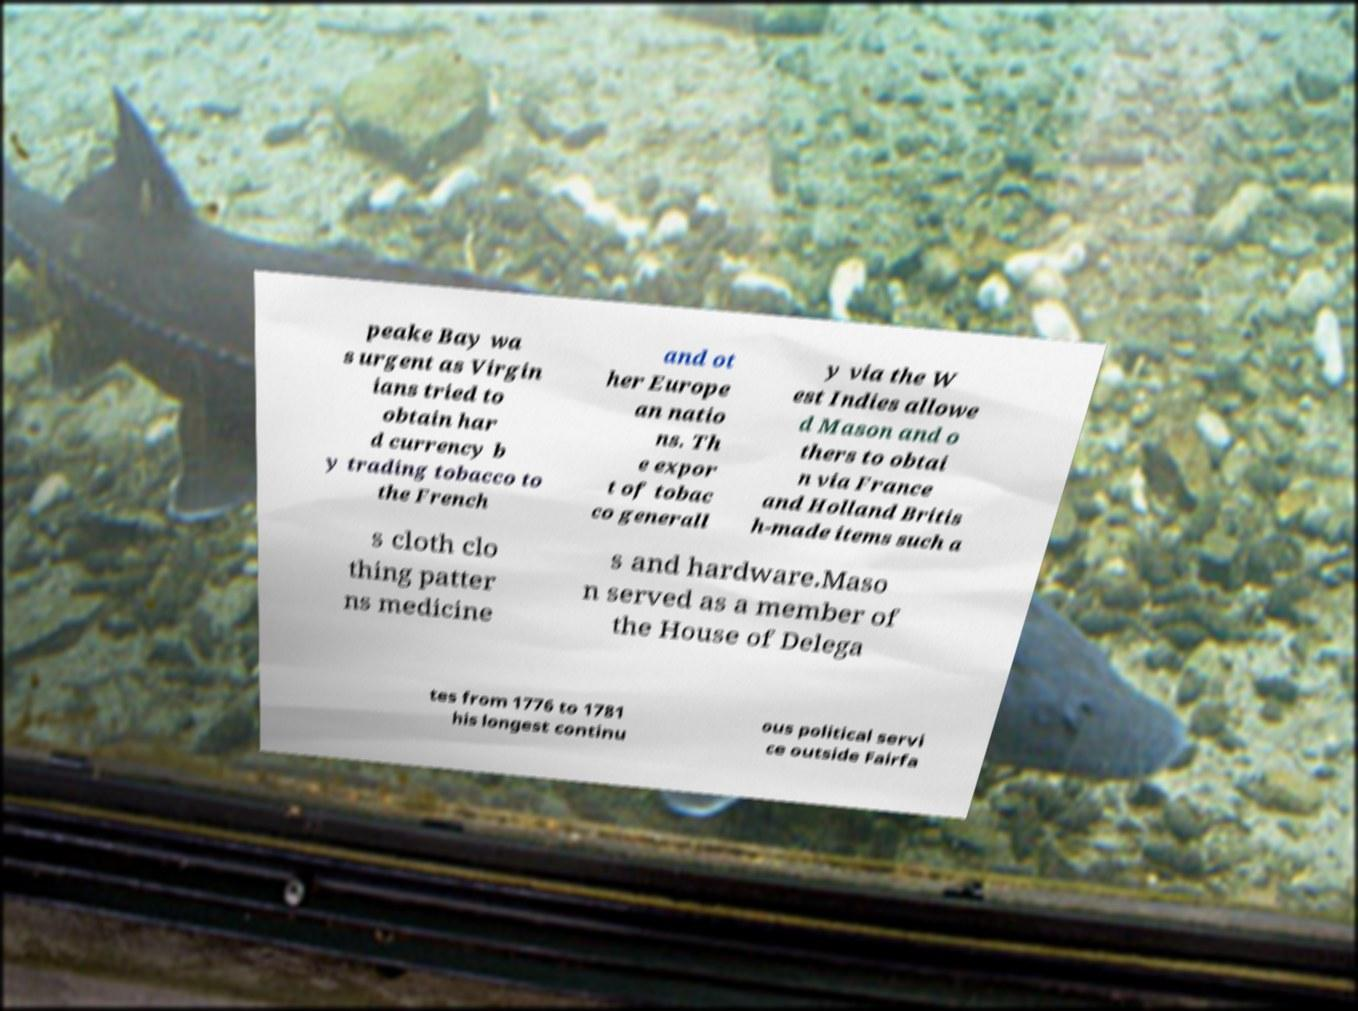What messages or text are displayed in this image? I need them in a readable, typed format. peake Bay wa s urgent as Virgin ians tried to obtain har d currency b y trading tobacco to the French and ot her Europe an natio ns. Th e expor t of tobac co generall y via the W est Indies allowe d Mason and o thers to obtai n via France and Holland Britis h-made items such a s cloth clo thing patter ns medicine s and hardware.Maso n served as a member of the House of Delega tes from 1776 to 1781 his longest continu ous political servi ce outside Fairfa 